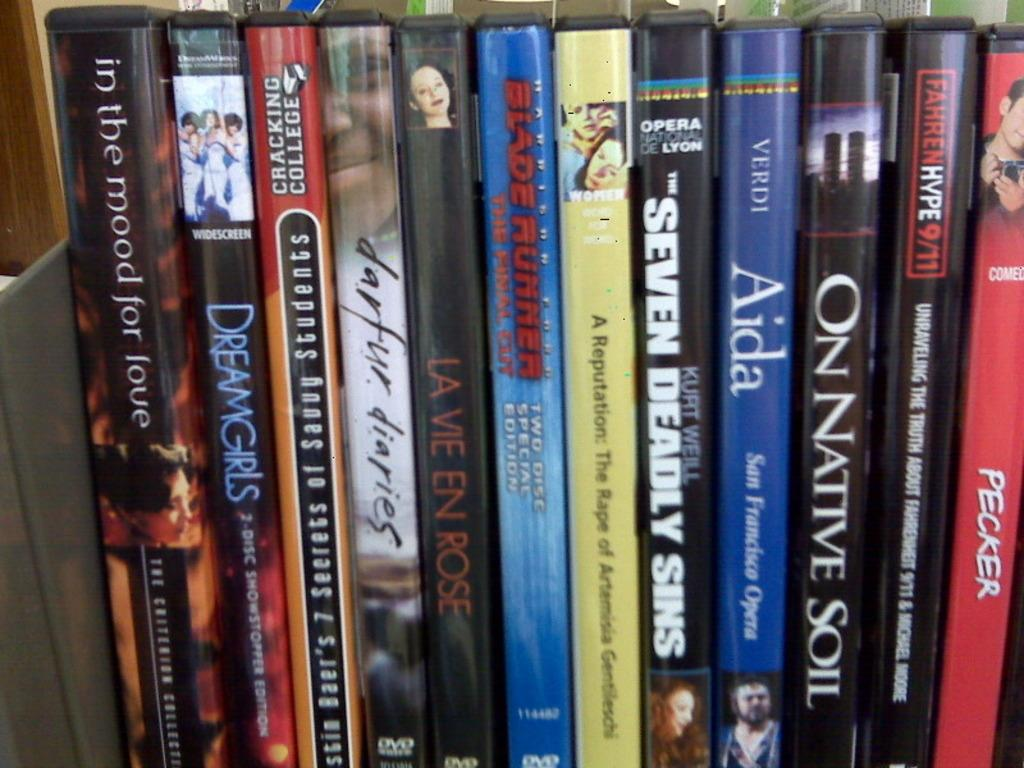<image>
Write a terse but informative summary of the picture. A group of DVD cases lined up starting with one called "In the mood for love" and ending with "Pecker" 